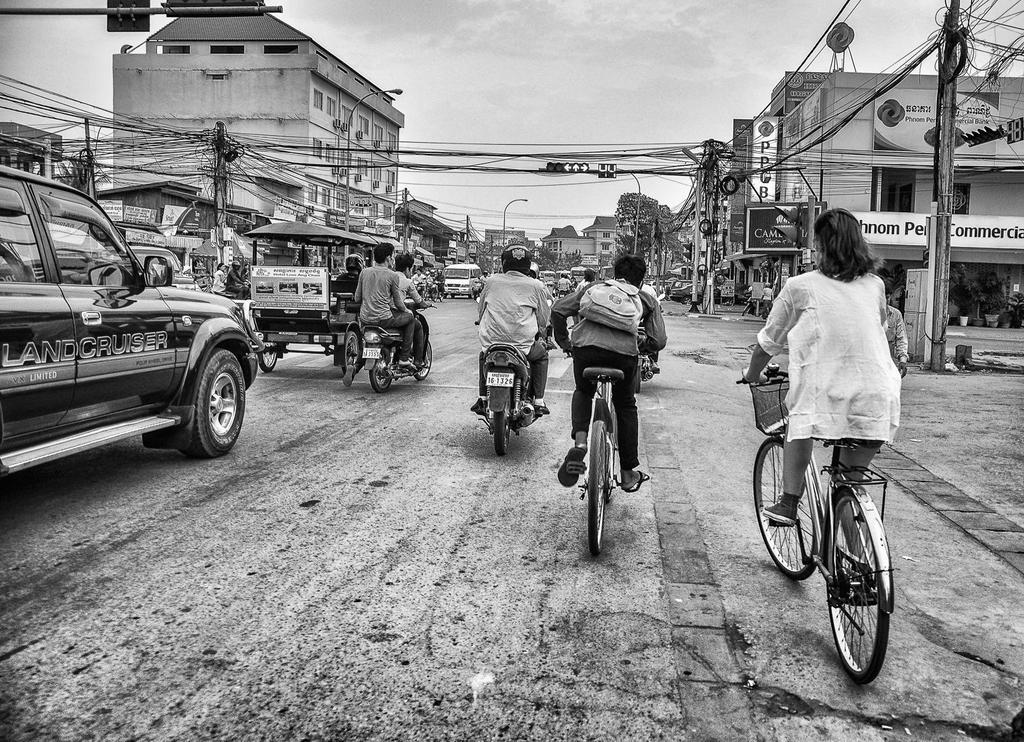What are the persons in the image doing? The persons in the image are riding a vehicle. Where is the vehicle located? The vehicle is on the road. What can be seen in the background of the image? There is a building and a traffic signal in the background of the image. What other object is present in the image? There is a pole in the image. What is visible above the vehicle and objects in the image? The sky is visible in the image. How many clovers are growing on the side of the road in the image? There are no clovers visible in the image; it features a vehicle on the road with a building and traffic signal in the background. 